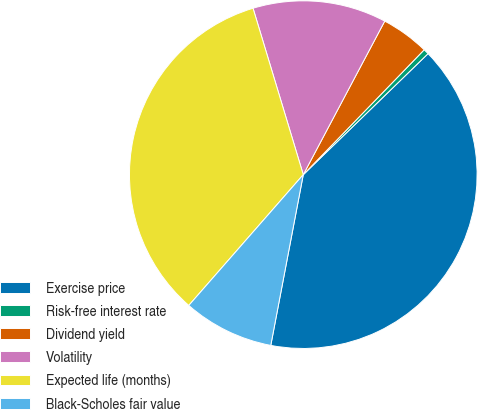<chart> <loc_0><loc_0><loc_500><loc_500><pie_chart><fcel>Exercise price<fcel>Risk-free interest rate<fcel>Dividend yield<fcel>Volatility<fcel>Expected life (months)<fcel>Black-Scholes fair value<nl><fcel>40.25%<fcel>0.5%<fcel>4.48%<fcel>12.43%<fcel>33.89%<fcel>8.45%<nl></chart> 